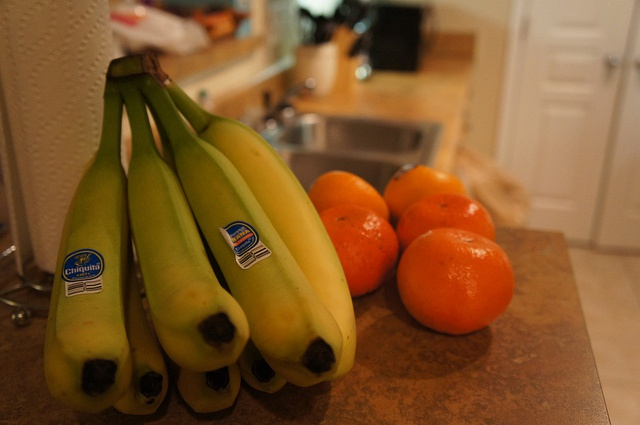Describe the objects in this image and their specific colors. I can see banana in maroon, olive, and black tones, dining table in maroon, brown, and black tones, orange in maroon, brown, and red tones, sink in maroon, brown, and gray tones, and orange in maroon, brown, and red tones in this image. 